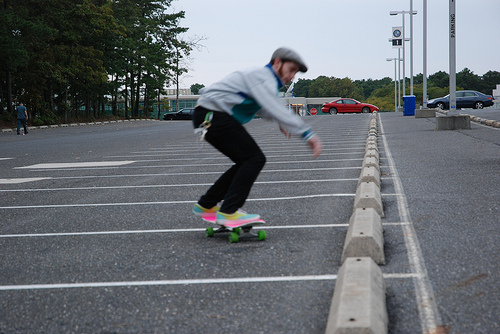How many people are skateboarding? In the image, there is one individual skateboarding, effortlessly gliding across the parking lot with focus and balance. 